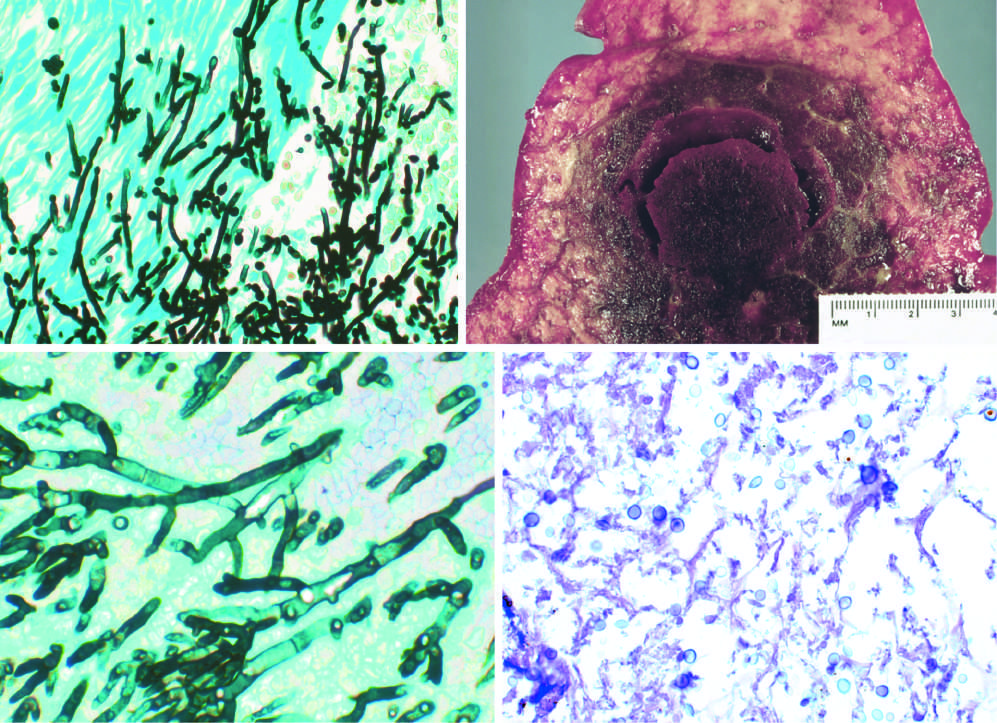what has pseudohyphae and budding yeasts?
Answer the question using a single word or phrase. Candida organism 